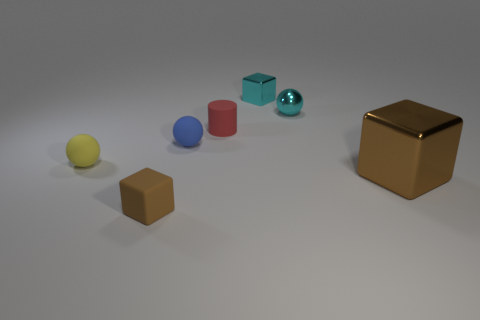There is a cyan sphere; is its size the same as the brown block that is left of the cyan shiny cube?
Keep it short and to the point. Yes. There is a tiny thing that is the same color as the big thing; what is it made of?
Offer a very short reply. Rubber. There is a brown object that is right of the blue object in front of the metallic block to the left of the large brown object; what is its size?
Your response must be concise. Large. Are there more tiny cyan spheres that are behind the cyan metallic cube than blocks that are behind the matte cylinder?
Provide a short and direct response. No. There is a large brown metallic cube that is behind the tiny brown rubber thing; how many brown things are in front of it?
Ensure brevity in your answer.  1. Are there any tiny balls that have the same color as the tiny metal cube?
Give a very brief answer. Yes. Is the red rubber object the same size as the brown metal cube?
Your answer should be compact. No. Is the color of the small metal block the same as the small metal ball?
Provide a succinct answer. Yes. What material is the small block that is behind the small matte sphere that is on the left side of the small blue matte object?
Your answer should be very brief. Metal. What is the material of the small yellow thing that is the same shape as the blue matte thing?
Offer a very short reply. Rubber. 